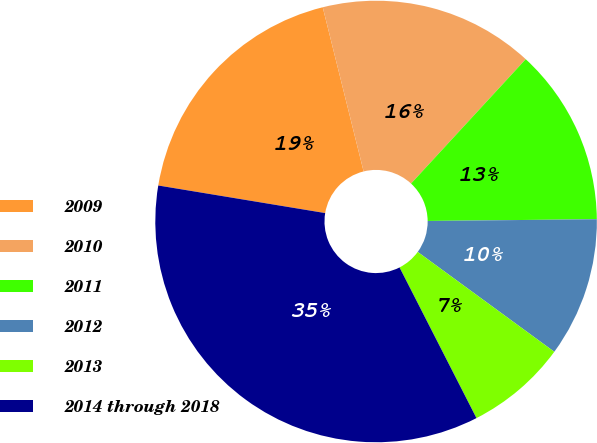Convert chart. <chart><loc_0><loc_0><loc_500><loc_500><pie_chart><fcel>2009<fcel>2010<fcel>2011<fcel>2012<fcel>2013<fcel>2014 through 2018<nl><fcel>18.51%<fcel>15.74%<fcel>12.98%<fcel>10.21%<fcel>7.44%<fcel>35.12%<nl></chart> 